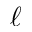<formula> <loc_0><loc_0><loc_500><loc_500>\ell</formula> 